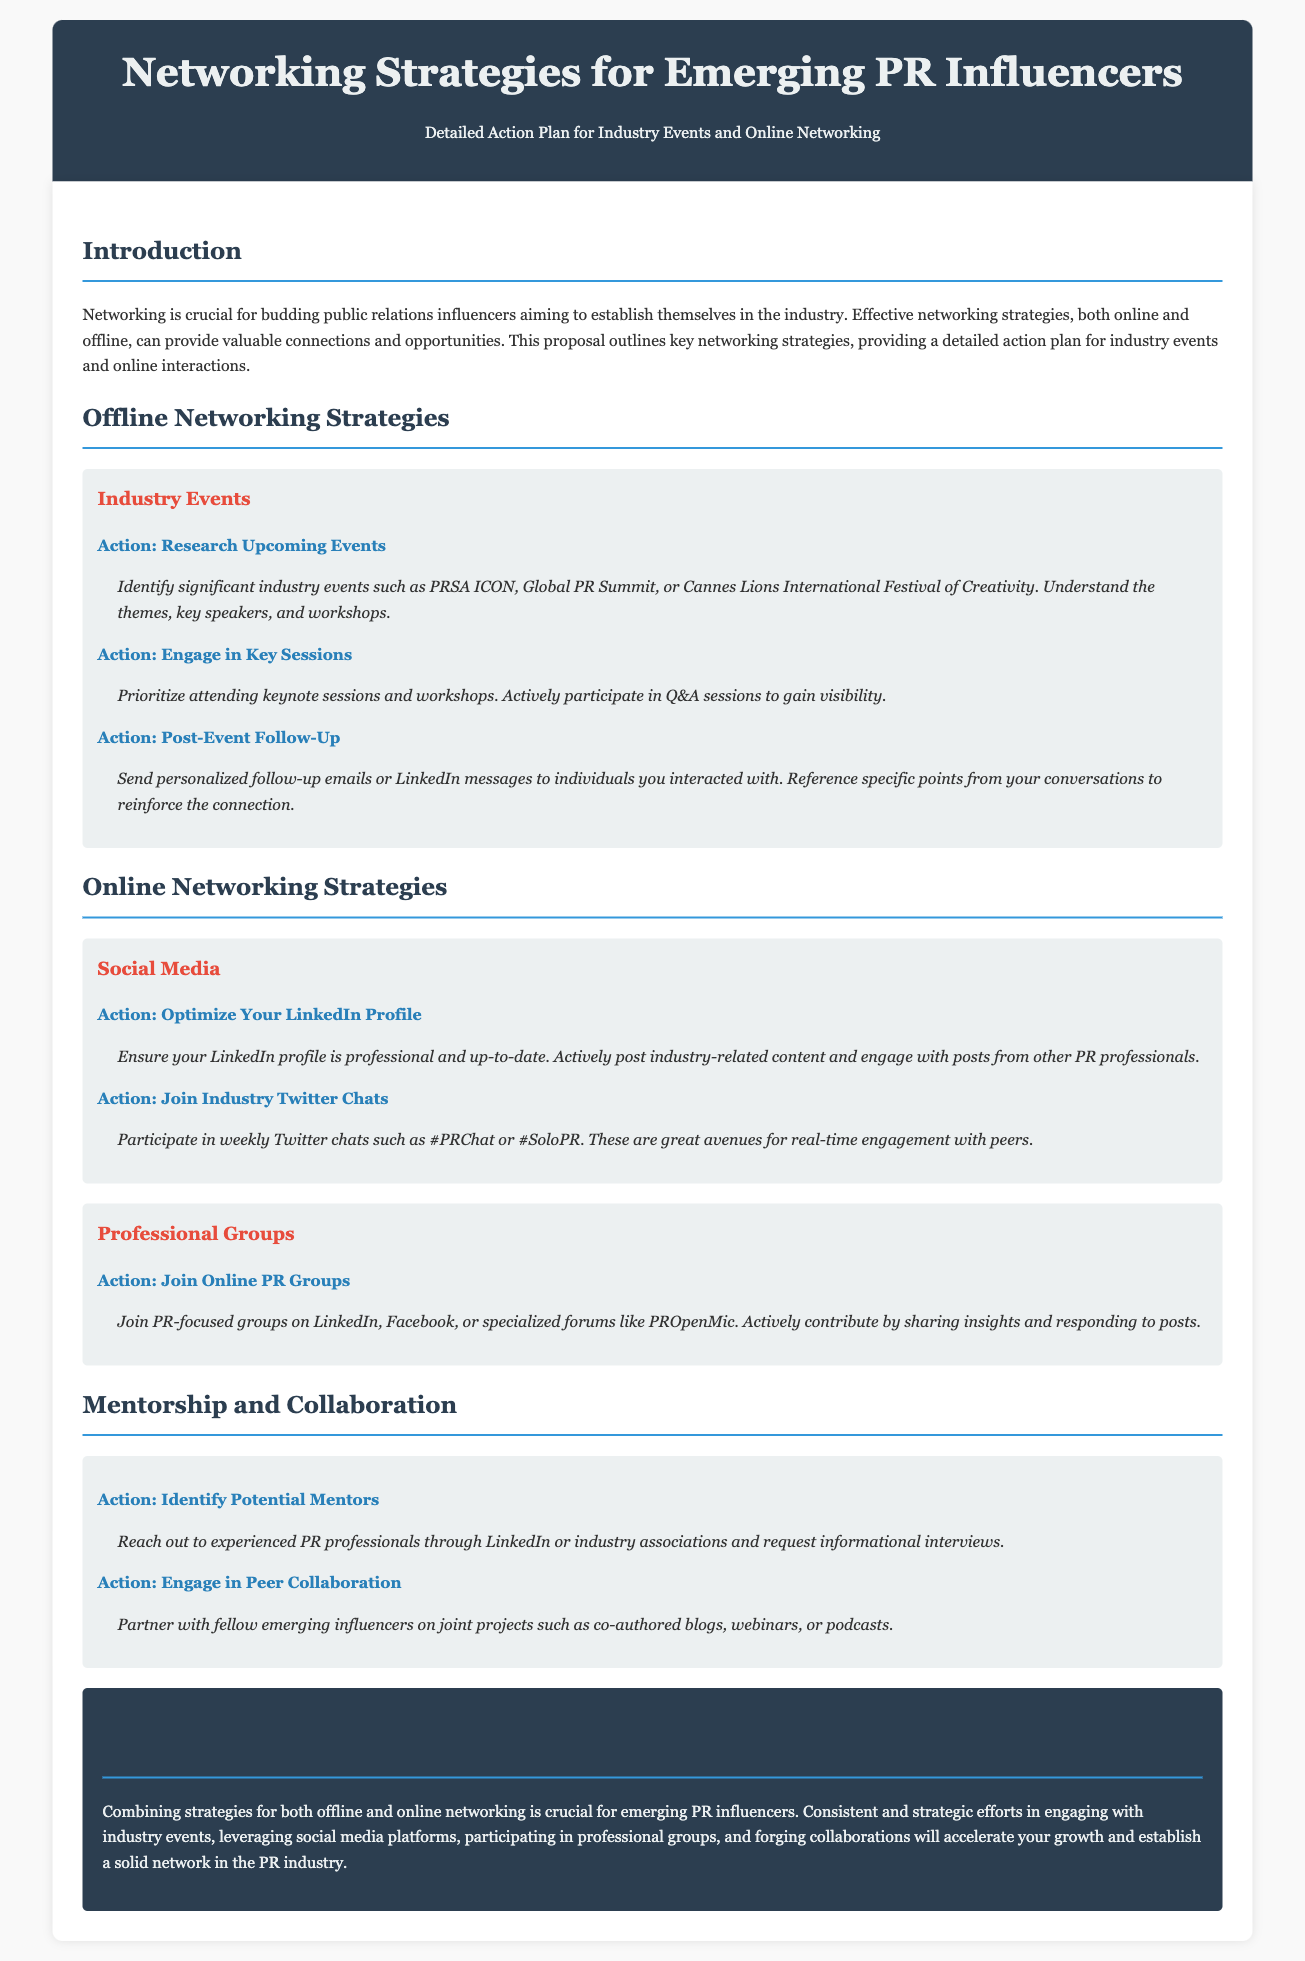What is the title of the document? The title is provided in the header section of the document.
Answer: Networking Strategies for Emerging PR Influencers What is the primary focus of this proposal? The introduction section outlines the main objective of the proposal.
Answer: Networking strategies Which industry events are mentioned for offline networking? The document lists specific events in the offline networking section.
Answer: PRSA ICON, Global PR Summit, Cannes Lions International Festival of Creativity What is one action suggested for online networking on LinkedIn? The online networking strategies section includes specific actions for LinkedIn.
Answer: Optimize Your LinkedIn Profile What is the purpose of sending personalized follow-up emails? This is discussed in the Offline Networking Strategies section under Post-Event Follow-Up.
Answer: Reinforce the connection Which Twitter chat is recommended for engagement? The online networking strategies section mentions specific Twitter chats.
Answer: #PRChat What type of collaboration is suggested among emerging influencers? The Mentorship and Collaboration section discusses specific collaborative actions.
Answer: Joint projects What color is used for the header background? The color of the header is specified by the CSS in the document.
Answer: #2c3e50 How is the conclusion described in the proposal? The conclusion section summarizes the overall message of the document.
Answer: Solid network in the PR industry 